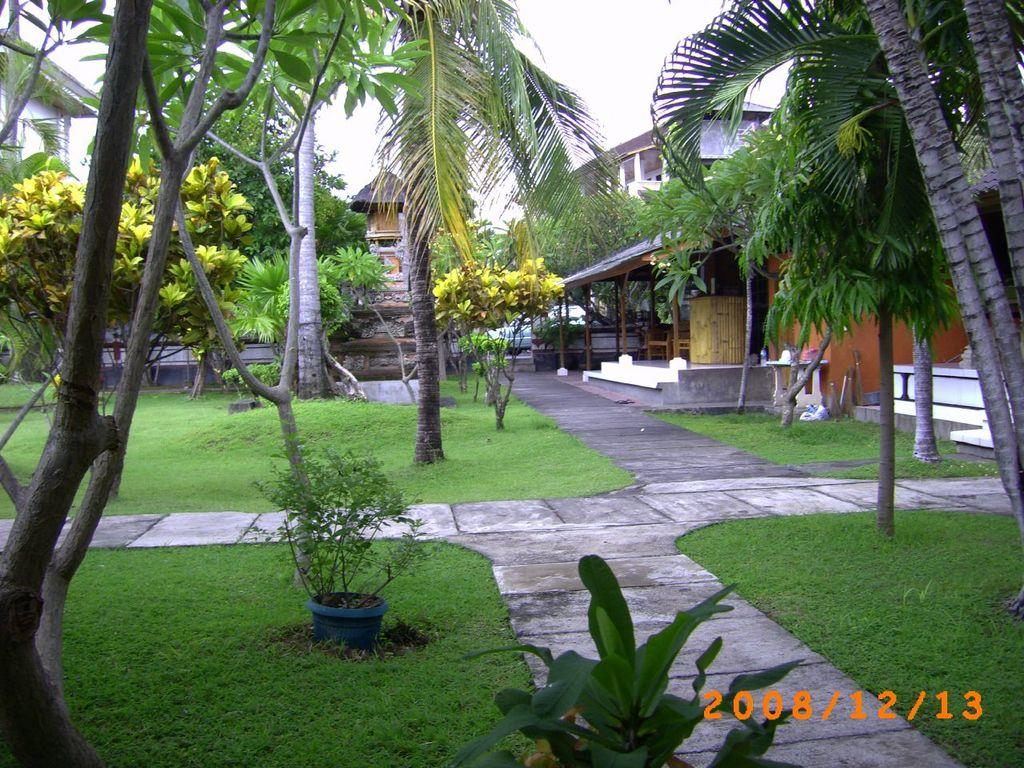What type of vegetation can be seen in the image? There are plants, trees, and grass visible in the image. What type of structures can be seen in the background of the image? There are buildings in the background of the image. What is visible at the top of the image? The sky is visible at the top of the image. Where is the text located in the image? The text is in the bottom right of the image. What type of vessel is being used to transport the pickle in the image? There is no vessel or pickle present in the image. How many wheels can be seen on the objects in the image? There are no objects with wheels present in the image. 